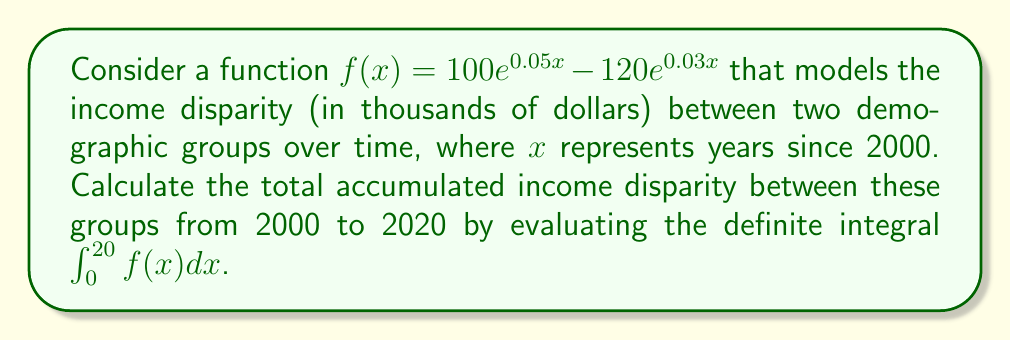Can you answer this question? To solve this problem, we need to evaluate the definite integral of $f(x)$ from 0 to 20. Let's break it down step-by-step:

1) First, let's rewrite the integral:

   $$\int_0^{20} (100e^{0.05x} - 120e^{0.03x}) dx$$

2) We can split this into two integrals:

   $$100\int_0^{20} e^{0.05x} dx - 120\int_0^{20} e^{0.03x} dx$$

3) For each integral, we can use the formula $\int e^{ax} dx = \frac{1}{a}e^{ax} + C$

4) For the first integral:
   $$100\int_0^{20} e^{0.05x} dx = 100 \cdot \frac{1}{0.05}[e^{0.05x}]_0^{20}$$
   $$= 2000[e^{1} - 1] = 2000(e - 1)$$

5) For the second integral:
   $$120\int_0^{20} e^{0.03x} dx = 120 \cdot \frac{1}{0.03}[e^{0.03x}]_0^{20}$$
   $$= 4000[e^{0.6} - 1]$$

6) Combining the results:
   $$2000(e - 1) - 4000(e^{0.6} - 1)$$

7) Simplifying:
   $$2000e - 2000 - 4000e^{0.6} + 4000$$
   $$= 2000e - 4000e^{0.6} + 2000$$

This result represents the total accumulated income disparity in thousands of dollars over the 20-year period.
Answer: $2000e - 4000e^{0.6} + 2000$ thousand dollars 